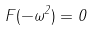<formula> <loc_0><loc_0><loc_500><loc_500>F ( - \omega ^ { 2 } ) = 0</formula> 